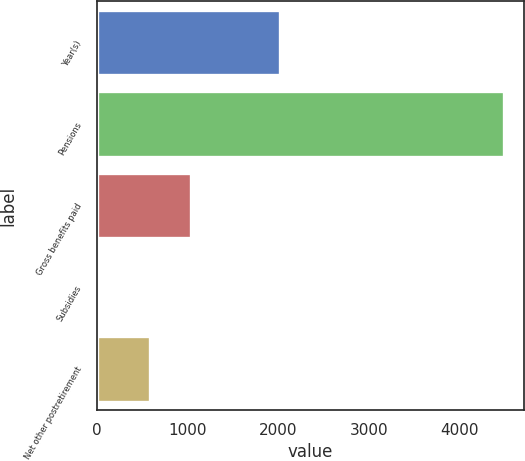Convert chart. <chart><loc_0><loc_0><loc_500><loc_500><bar_chart><fcel>Year(s)<fcel>Pensions<fcel>Gross benefits paid<fcel>Subsidies<fcel>Net other postretirement<nl><fcel>2020<fcel>4488<fcel>1034.1<fcel>37<fcel>589<nl></chart> 